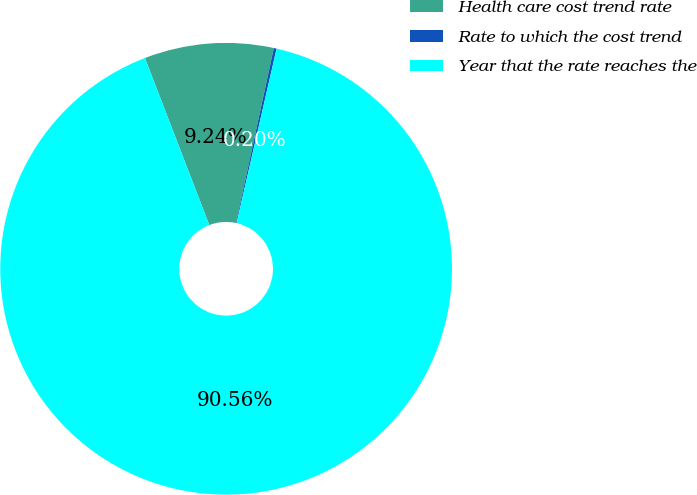Convert chart. <chart><loc_0><loc_0><loc_500><loc_500><pie_chart><fcel>Health care cost trend rate<fcel>Rate to which the cost trend<fcel>Year that the rate reaches the<nl><fcel>9.24%<fcel>0.2%<fcel>90.56%<nl></chart> 